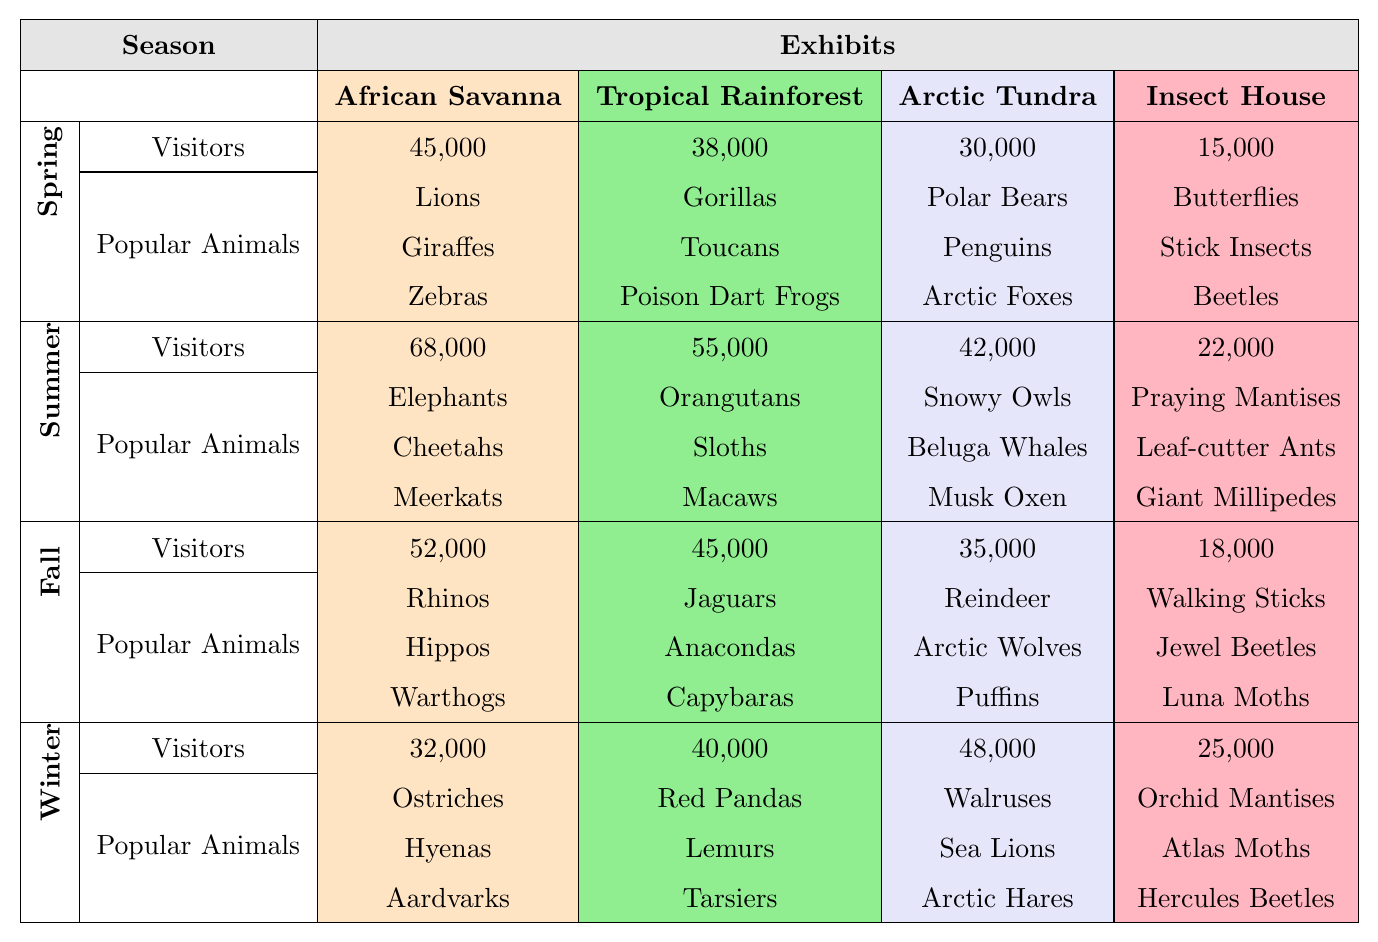What season had the highest attendance at the African Savanna exhibit? The highest attendance at the African Savanna exhibit occurred in Summer with 68,000 visitors. I found this number by comparing the visitors' numbers for each season listed under that exhibit.
Answer: Summer Which animal was the most popular in the Tropical Rainforest during Spring? The most popular animals in the Tropical Rainforest during Spring were Gorillas, Toucans, and Poison Dart Frogs. This information was taken directly from the table under Spring for the Tropical Rainforest exhibit.
Answer: Gorillas, Toucans, and Poison Dart Frogs What is the total number of visitors for the Insect House across all seasons? To find the total number of visitors for the Insect House, I added the visitor numbers from each season: 15,000 (Spring) + 22,000 (Summer) + 18,000 (Fall) + 25,000 (Winter) = 80,000.
Answer: 80,000 Did the Arctic Tundra exhibit see more visitors in Winter compared to Fall? Yes, the Arctic Tundra had 48,000 visitors in Winter and only 35,000 in Fall, so it did see more visitors in Winter. I compared the numbers for each season for that specific exhibit.
Answer: Yes What is the average number of visitors for the African Savanna across all seasons? I first added the visitor numbers for the African Savanna: 45,000 (Spring) + 68,000 (Summer) + 52,000 (Fall) + 32,000 (Winter) = 197,000. Then I divided by 4 (the number of seasons): 197,000 / 4 = 49,250.
Answer: 49,250 Which exhibit had the least number of visitors during Fall? The Insect House had the least number of visitors during Fall with 18,000. I compared the visitor numbers for all exhibits listed under Fall.
Answer: Insect House What is the difference in visitors between the Arctic Tundra in Winter and the Tropical Rainforest in Summer? The Arctic Tundra had 48,000 visitors in Winter, while the Tropical Rainforest had 55,000 visitors in Summer. The difference is 55,000 - 48,000 = 7,000.
Answer: 7,000 During which season did the Insect House see the highest attendance? The Insect House had the highest attendance in Winter with 25,000 visitors. I looked at the visitor numbers for each season under the Insect House.
Answer: Winter How many more visitors did the African Savanna have in Summer compared to Winter? In Summer, the African Savanna had 68,000 visitors and in Winter, it had 32,000 visitors. The difference is 68,000 - 32,000 = 36,000.
Answer: 36,000 Is it true that in Spring the Tropical Rainforest had more visitors than the Arctic Tundra? Yes, it is true. The Tropical Rainforest had 38,000 visitors, while the Arctic Tundra had 30,000 visitors in Spring. I compared the numbers from Spring for both exhibits.
Answer: Yes 